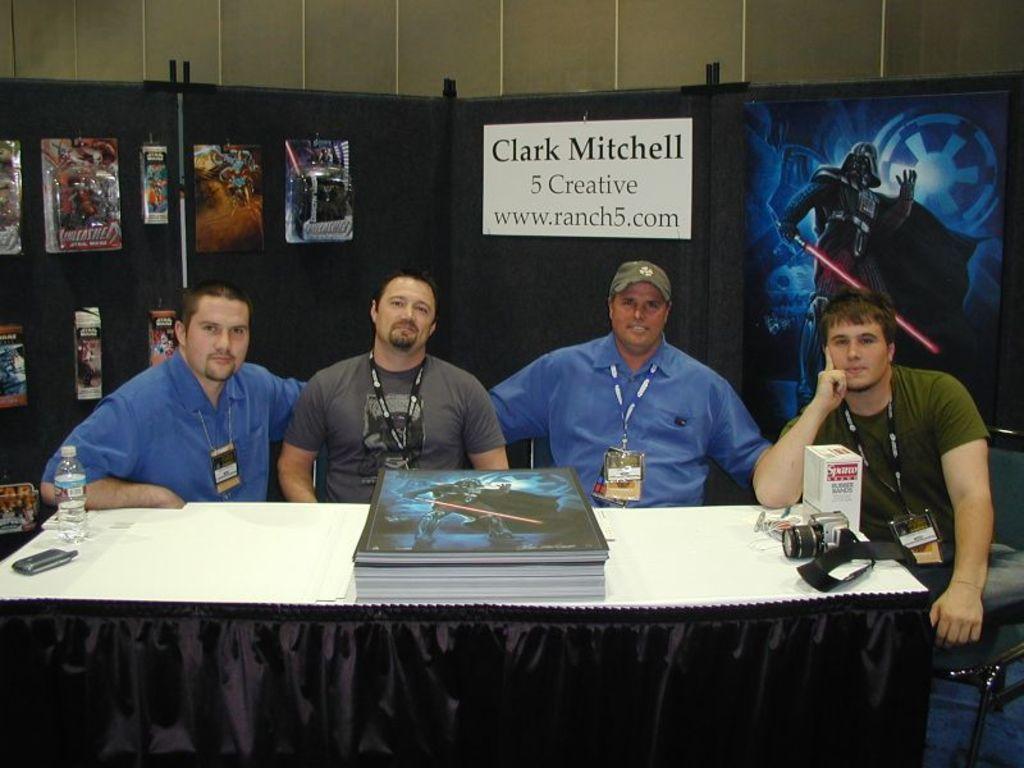Can you describe this image briefly? In this picture we can see people sitting on chairs, they are wearing id cards, in front of them we can see a table, on this table we can see a bottle, mobile, books, camera, box, some objects and in the background we can see a wall, posters and name board. 